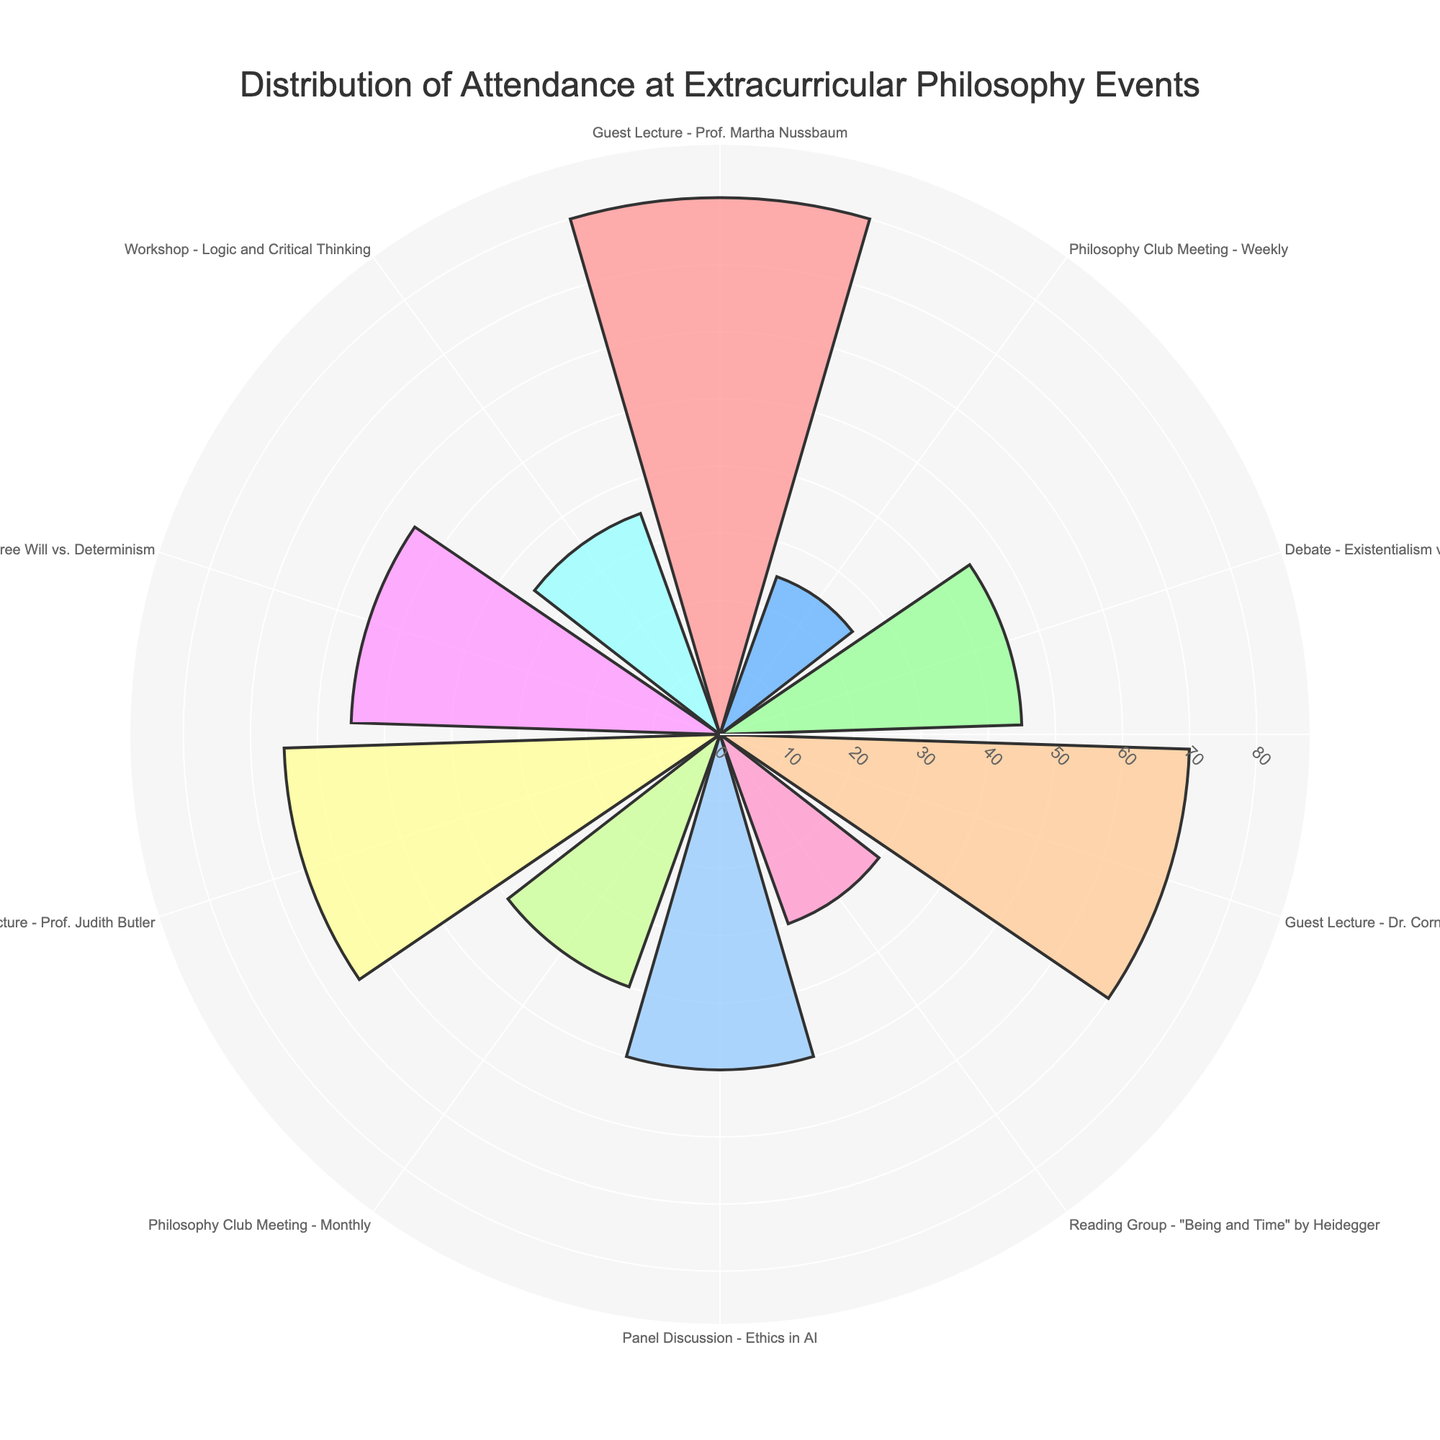What's the title of the chart? The title is usually displayed at the top of a chart and provides a summary of what the chart is about. In this case, it should be visible and easy to read.
Answer: Distribution of Attendance at Extracurricular Philosophy Events How many events had more than 50 attendees? To find the number of events with more than 50 attendees, we look at the bars extending beyond the 50-attendee mark.
Answer: Four events Which event had the highest attendance? By examining the length of all the bars, the tallest one represents the event with the highest number of attendees.
Answer: Guest Lecture - Prof. Martha Nussbaum What is the total attendance for all events combined? To find the total attendance, sum up the number of attendees for all events. Each bar's length in the chart represents these numbers.
Answer: 495 Which guest lecture had fewer attendees, Prof. Judith Butler's or Dr. Cornel West's? Compare the bar lengths representing both guest lectures. The shorter bar indicates fewer attendees.
Answer: Prof. Judith Butler's How does the attendance for the Workshop - Logic and Critical Thinking compare to the average attendance of all events? Calculate the average attendance by dividing the total attendance by the number of events. Then, compare this to the attendance for the specified workshop.
Answer: Below average What's the difference in attendance between the event with the highest and lowest attendance? Identify the highest and lowest values, then subtract the lowest from the highest.
Answer: 55 How many different colors are used in the chart? Count the number of distinct colors used to fill the bars representing different events.
Answer: Ten colors Which debate had more attendees, Existentialism vs. Absurdism or Free Will vs. Determinism? Compare the bar lengths for both debates. The longer bar indicates higher attendance.
Answer: Free Will vs. Determinism What's the average attendance for guest lectures? Sum the number of attendees for all guest lectures and divide by the number of guest lecture events.
Answer: 71.67 